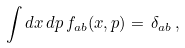Convert formula to latex. <formula><loc_0><loc_0><loc_500><loc_500>\int d x \, d p \, f _ { a b } ( x , p ) = \, \delta _ { a b } \, ,</formula> 